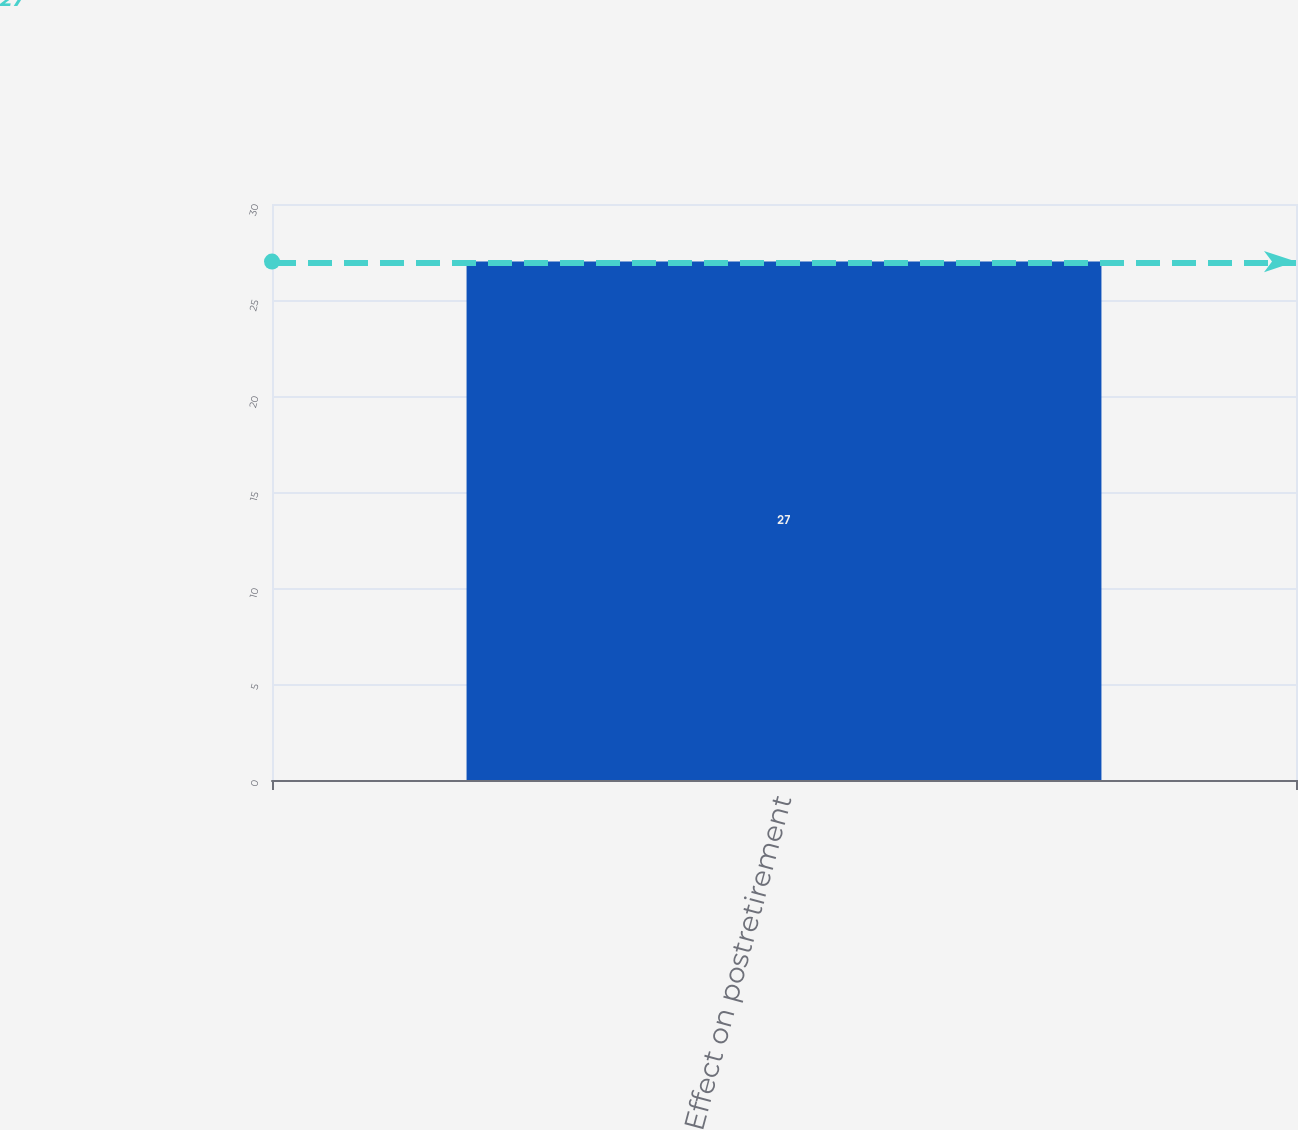<chart> <loc_0><loc_0><loc_500><loc_500><bar_chart><fcel>Effect on postretirement<nl><fcel>27<nl></chart> 